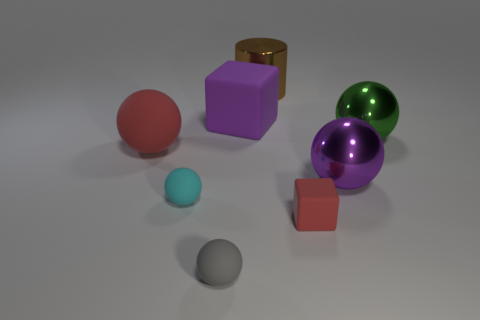Subtract all purple spheres. How many spheres are left? 4 Subtract all purple spheres. How many spheres are left? 4 Subtract 1 balls. How many balls are left? 4 Add 1 gray objects. How many objects exist? 9 Subtract all red balls. Subtract all cyan cubes. How many balls are left? 4 Subtract all cylinders. How many objects are left? 7 Add 6 tiny gray matte things. How many tiny gray matte things are left? 7 Add 3 purple spheres. How many purple spheres exist? 4 Subtract 0 gray cylinders. How many objects are left? 8 Subtract all red objects. Subtract all tiny green matte balls. How many objects are left? 6 